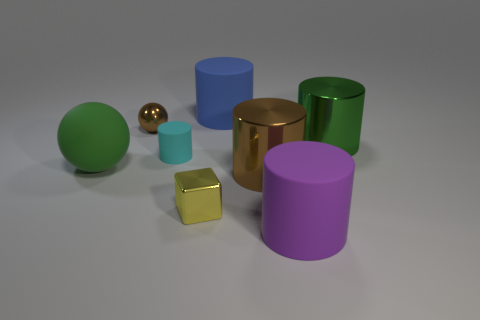Subtract all blue cylinders. How many cylinders are left? 4 Subtract all large purple cylinders. How many cylinders are left? 4 Subtract 2 cylinders. How many cylinders are left? 3 Subtract all yellow cylinders. Subtract all brown balls. How many cylinders are left? 5 Add 2 brown metallic things. How many objects exist? 10 Subtract all balls. How many objects are left? 6 Add 1 large purple matte things. How many large purple matte things are left? 2 Add 6 large yellow rubber objects. How many large yellow rubber objects exist? 6 Subtract 1 cyan cylinders. How many objects are left? 7 Subtract all tiny gray matte cylinders. Subtract all large rubber things. How many objects are left? 5 